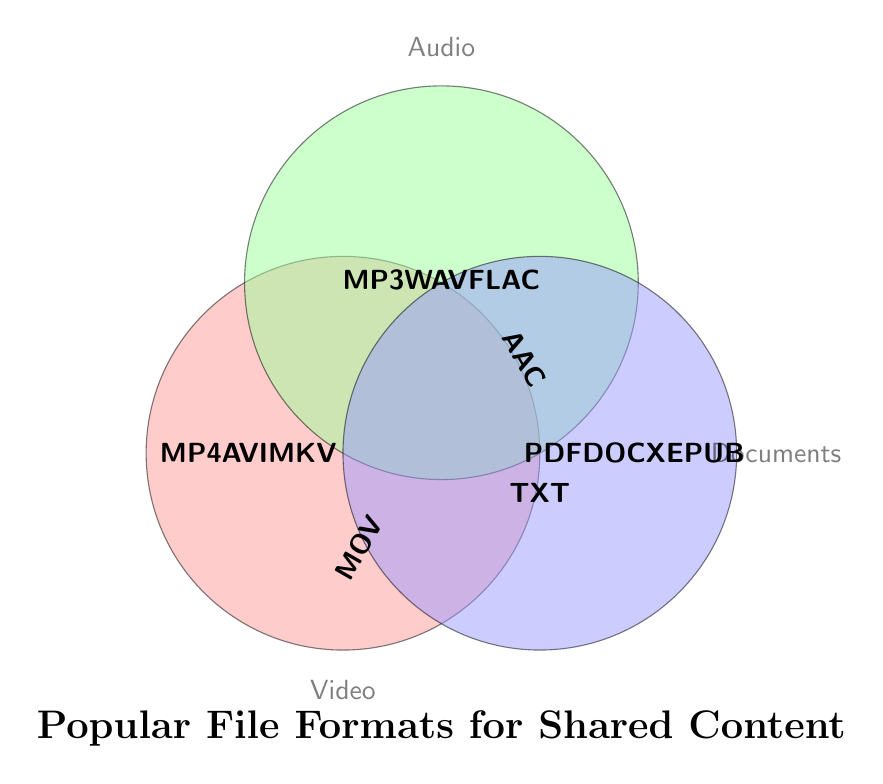What is the title of the Venn diagram? The title of the Venn diagram is positioned at the bottom of the figure and is written in a large bold font. It reads "Popular File Formats for Shared Content."
Answer: Popular File Formats for Shared Content Which circle represents video file formats? Three circles overlap in the Venn diagram, each with a label. The circle labeled "Video" is positioned on the left side of the figure and is filled with a pinkish color.
Answer: The left circle How many video file formats are listed? The labels within the pinkish "Video" circle list the file formats associated with it. These labels are arranged vertically in the circle and include MP4, AVI, and MKV. The total count is three.
Answer: 3 Which file format is uniquely placed in the Audio circle? The center circle labeled "Audio" contains a unique entry "AAC" positioned outside the overlaps with other circles, indicating it belongs solely to Audio.
Answer: AAC How many formats are inside the Documents circle? The blueish "Documents" circle located on the right side contains the file formats PDF, DOCX, EPUB, and TXT. A total of four formats.
Answer: 4 What file formats are common between Video and Audio? To identify the common formats between Video and Audio, check the overlap between the Video and Audio circles. This area is empty, so there are no common formats.
Answer: None Which file formats are listed for Documents? Inside the blueish "Documents" circle, the file formats listed are PDF, DOCX, EPUB, and TXT.
Answer: PDF, DOCX, EPUB, TXT Which file format appears in the overlapping section of Video and Documents circles? The overlap section between the Video and Documents circles contains "MOV", which belongs to both categories.
Answer: MOV How many file formats are mentioned in total? Count all unique file formats mentioned in the Venn diagram for Video, Audio, and Documents. The total unique formats are MP4, AVI, MKV, MOV, WMV, MP3, WAV, FLAC, AAC, OGG, PDF, DOCX, EPUB, MOBI, and TXT.
Answer: 15 What formats are placed in the center of the Venn diagram? The central overlap section, where all three circles intersect, contains no file formats, indicating no common formats among Video, Audio, and Documents.
Answer: None 